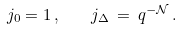<formula> <loc_0><loc_0><loc_500><loc_500>j _ { 0 } = 1 \, , \quad j _ { \Delta } \, = \, q ^ { - \mathcal { N } } \, .</formula> 